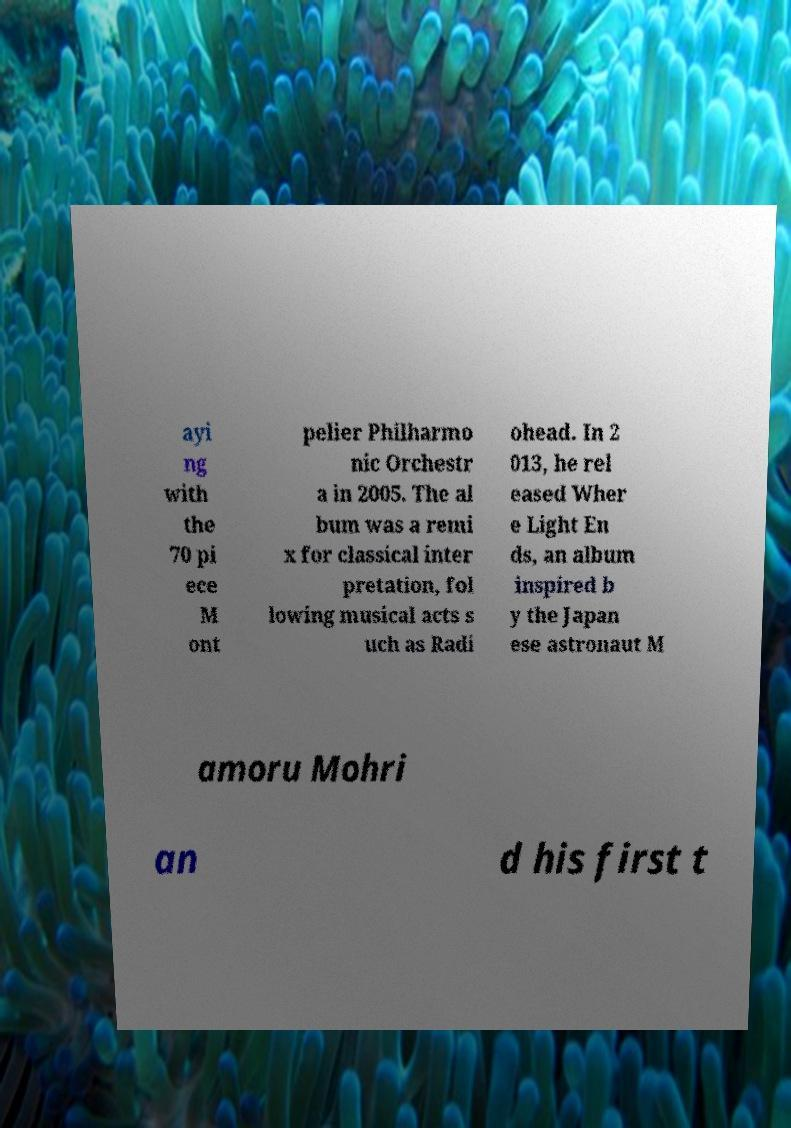There's text embedded in this image that I need extracted. Can you transcribe it verbatim? ayi ng with the 70 pi ece M ont pelier Philharmo nic Orchestr a in 2005. The al bum was a remi x for classical inter pretation, fol lowing musical acts s uch as Radi ohead. In 2 013, he rel eased Wher e Light En ds, an album inspired b y the Japan ese astronaut M amoru Mohri an d his first t 